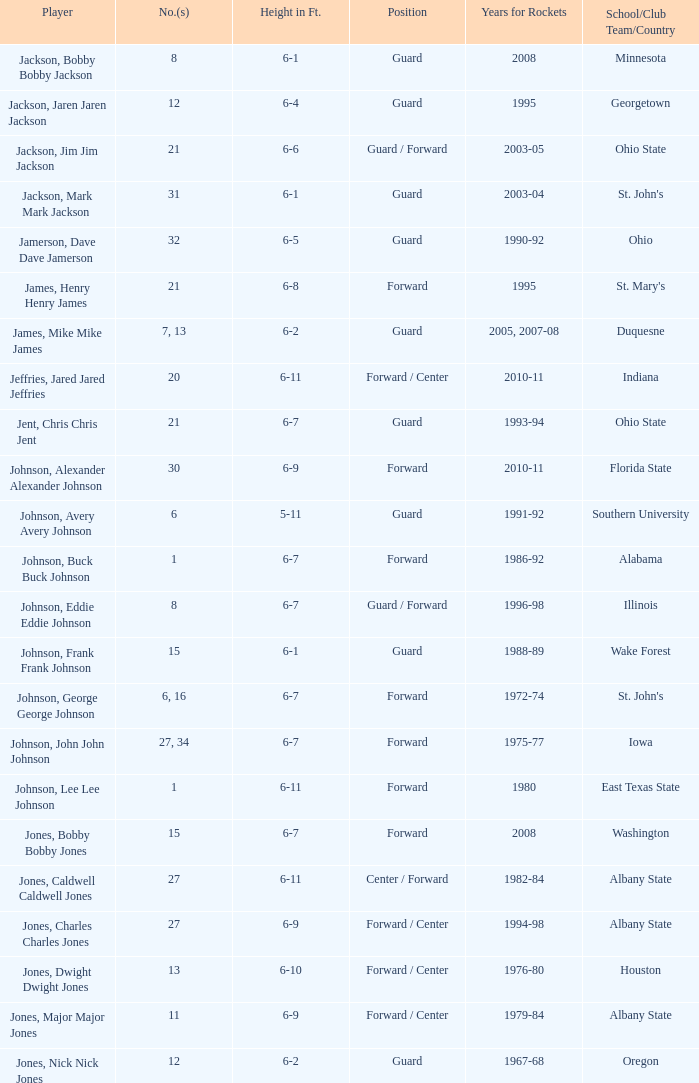How tall is the player jones, major major jones? 6-9. 